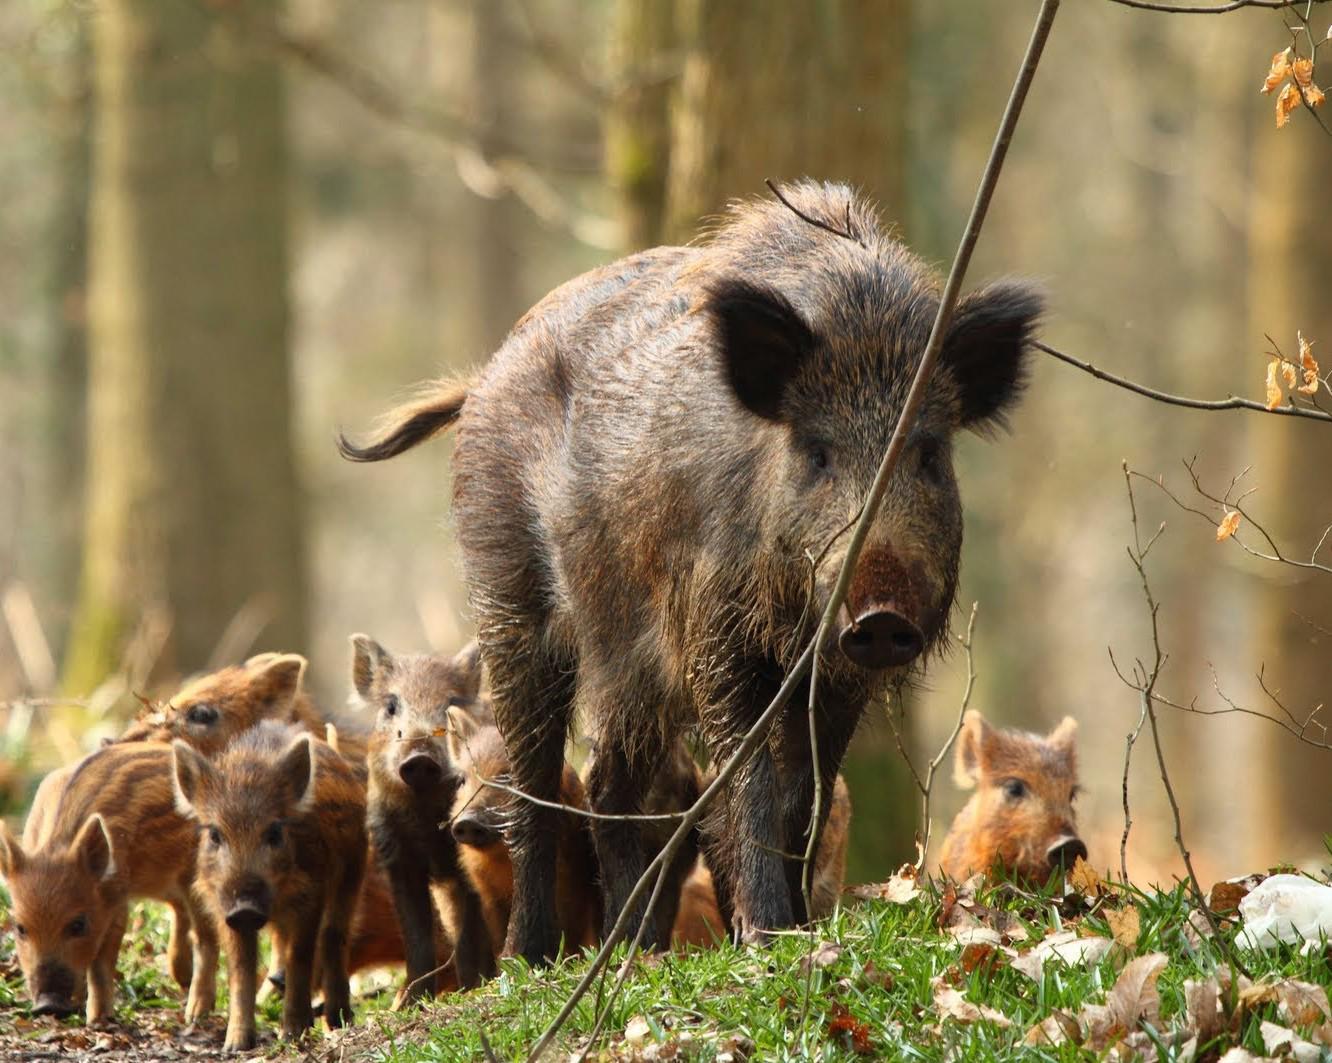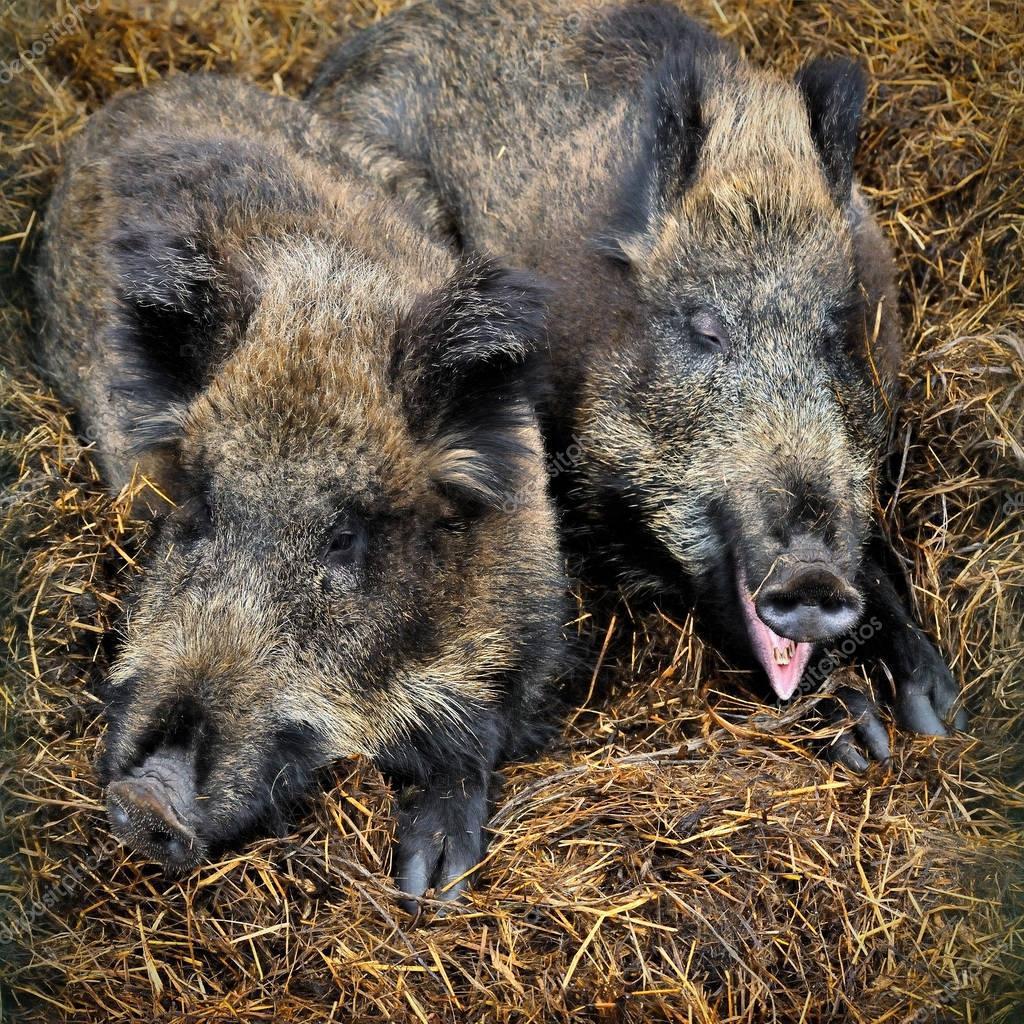The first image is the image on the left, the second image is the image on the right. For the images shown, is this caption "There are exactly four pigs." true? Answer yes or no. No. The first image is the image on the left, the second image is the image on the right. For the images displayed, is the sentence "An image contains at least two baby piglets with distinctive brown and beige striped fur, who are standing on all fours and facing forward." factually correct? Answer yes or no. Yes. 